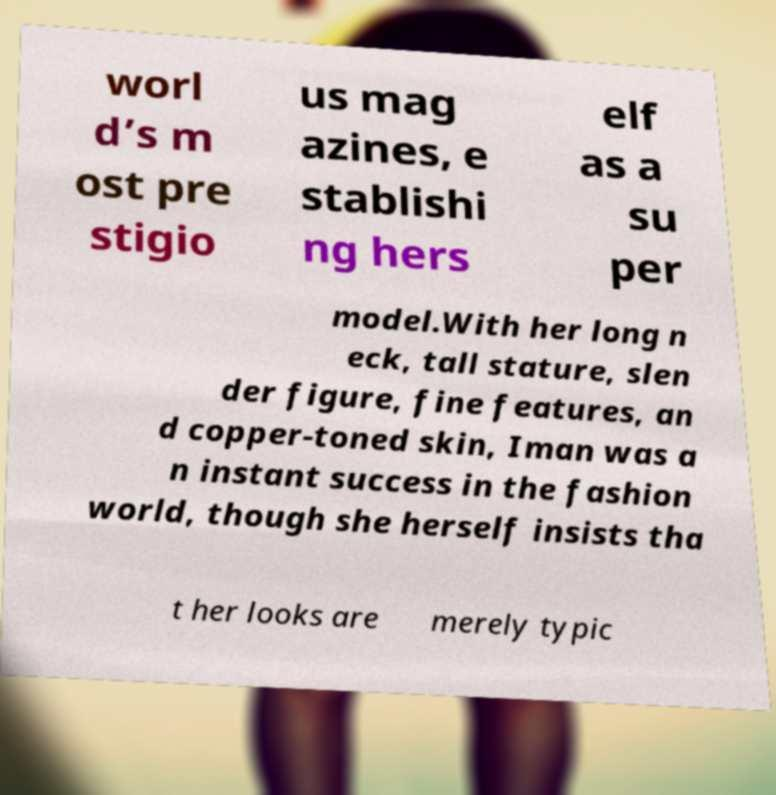Could you extract and type out the text from this image? worl d’s m ost pre stigio us mag azines, e stablishi ng hers elf as a su per model.With her long n eck, tall stature, slen der figure, fine features, an d copper-toned skin, Iman was a n instant success in the fashion world, though she herself insists tha t her looks are merely typic 